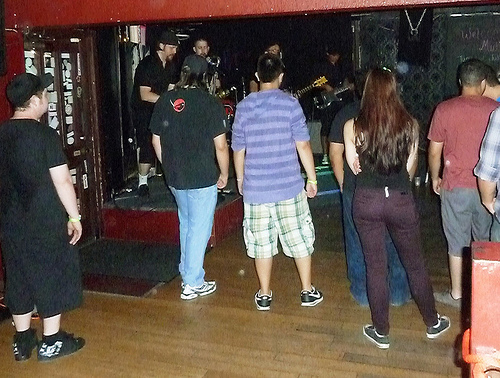<image>
Can you confirm if the shoes is on the person? No. The shoes is not positioned on the person. They may be near each other, but the shoes is not supported by or resting on top of the person. Is there a woman to the left of the man? No. The woman is not to the left of the man. From this viewpoint, they have a different horizontal relationship. Is the man behind the woman? No. The man is not behind the woman. From this viewpoint, the man appears to be positioned elsewhere in the scene. Is the girl next to the boy? No. The girl is not positioned next to the boy. They are located in different areas of the scene. 